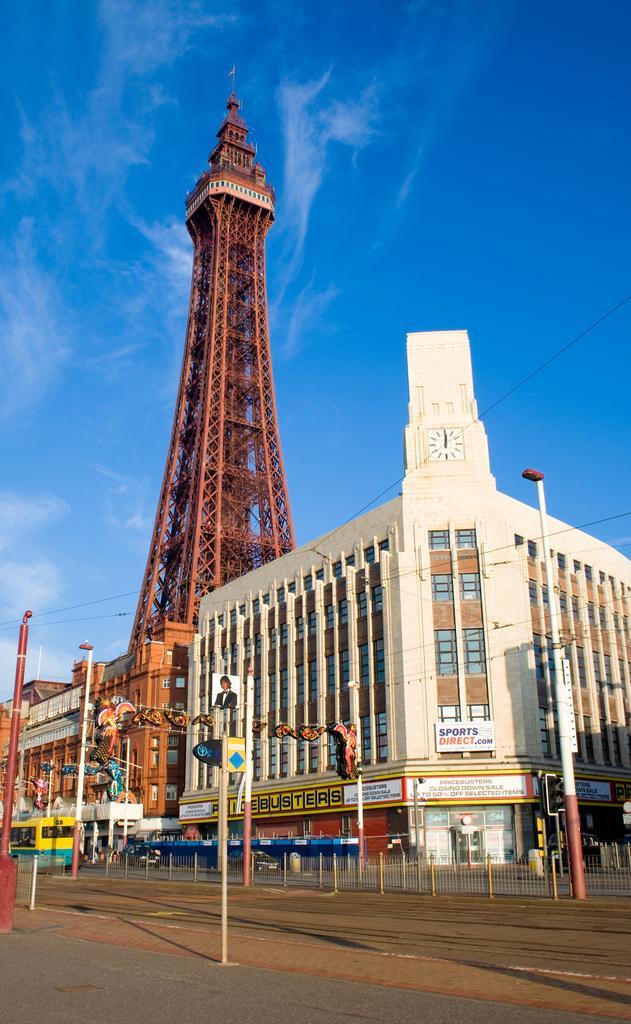Describe this image in one or two sentences. In the foreground of this image, there is road, pavement, bollards and pole. In the background, there are buildings, boards, tower, sky and the cloud. 